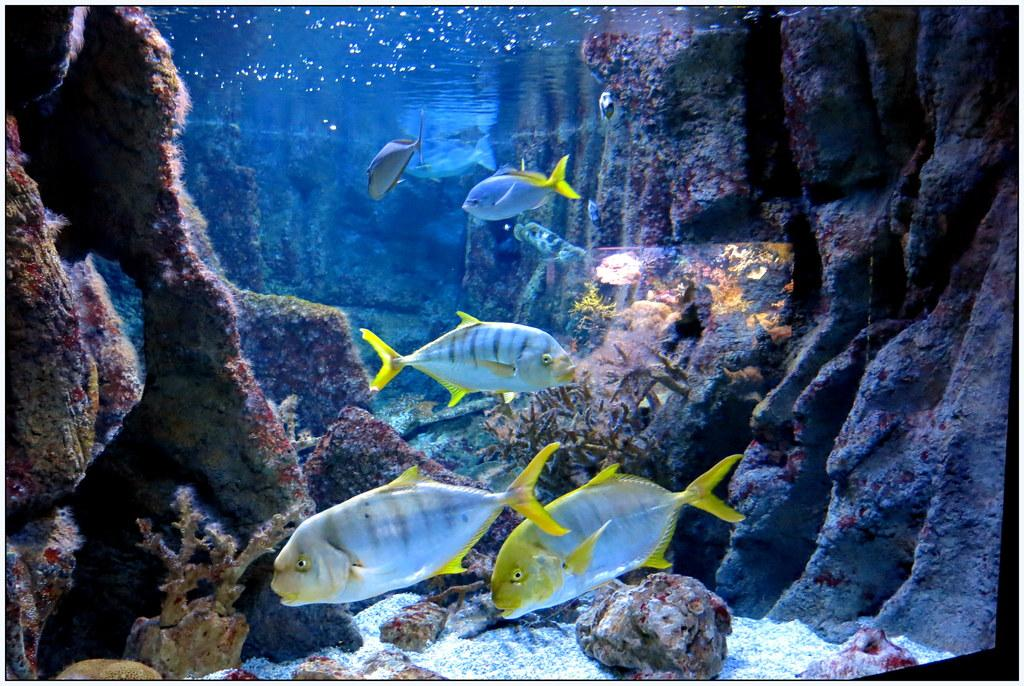What type of animals can be seen in the image? There are fish in the water in the image. What colors are the fish? The fish are in blue and yellow colors. What else can be seen in the water besides the fish? Aquatic plants are visible in the image. Where is the chair located in the image? There is no chair present in the image. What type of fairies can be seen flying around the fish in the image? There are no fairies present in the image; it features fish in blue and yellow colors with aquatic plants. 